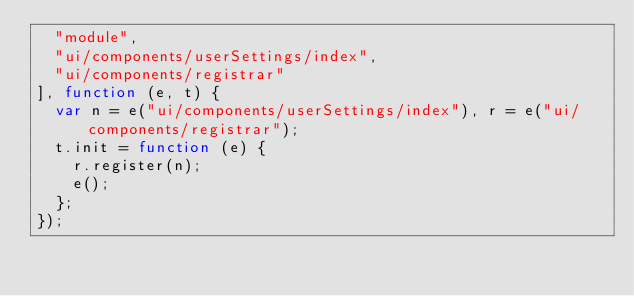Convert code to text. <code><loc_0><loc_0><loc_500><loc_500><_JavaScript_>  "module",
  "ui/components/userSettings/index",
  "ui/components/registrar"
], function (e, t) {
  var n = e("ui/components/userSettings/index"), r = e("ui/components/registrar");
  t.init = function (e) {
    r.register(n);
    e();
  };
});
</code> 